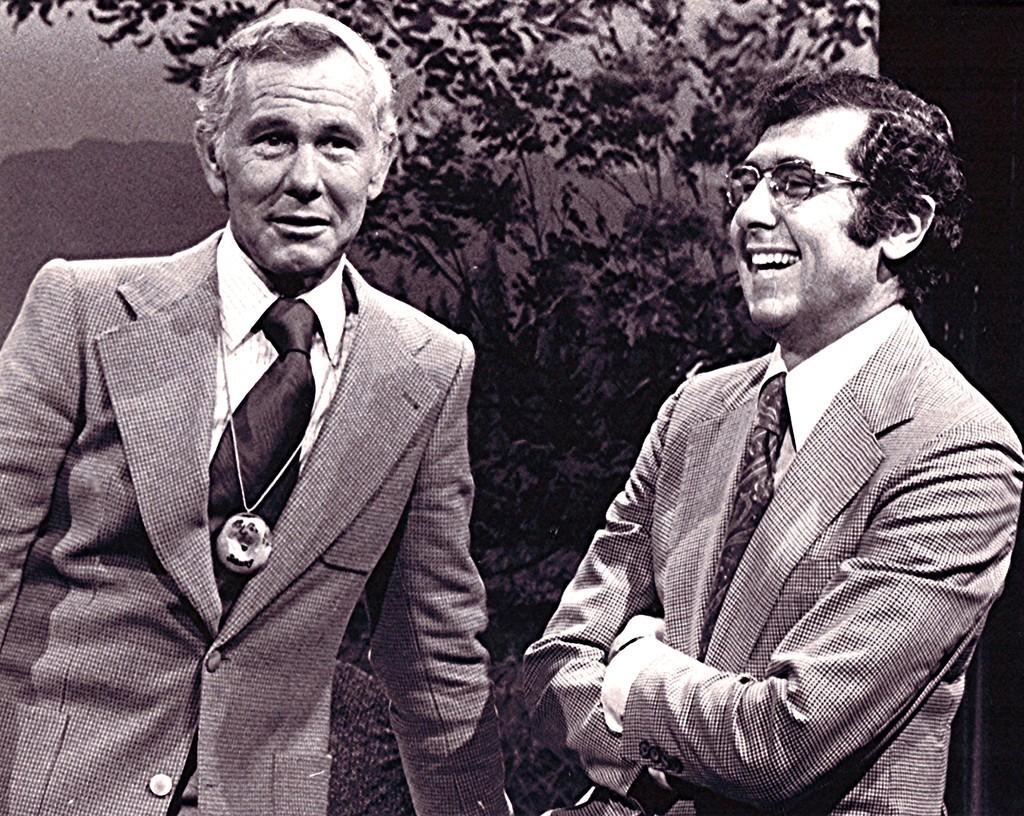Could you give a brief overview of what you see in this image? This is a black and white image. In this image we can see two persons. Person on the right side is wearing specs. In the background there are trees. 